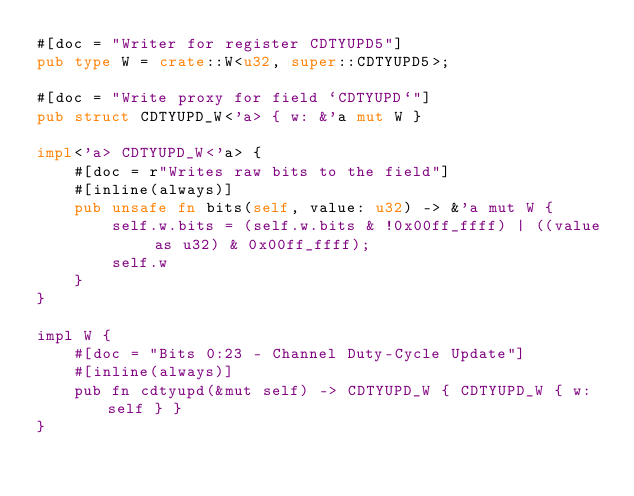Convert code to text. <code><loc_0><loc_0><loc_500><loc_500><_Rust_>#[doc = "Writer for register CDTYUPD5"]
pub type W = crate::W<u32, super::CDTYUPD5>;

#[doc = "Write proxy for field `CDTYUPD`"]
pub struct CDTYUPD_W<'a> { w: &'a mut W }

impl<'a> CDTYUPD_W<'a> {
    #[doc = r"Writes raw bits to the field"]
    #[inline(always)]
    pub unsafe fn bits(self, value: u32) -> &'a mut W {
        self.w.bits = (self.w.bits & !0x00ff_ffff) | ((value as u32) & 0x00ff_ffff);
        self.w
    }
}

impl W {
    #[doc = "Bits 0:23 - Channel Duty-Cycle Update"]
    #[inline(always)]
    pub fn cdtyupd(&mut self) -> CDTYUPD_W { CDTYUPD_W { w: self } }
}</code> 